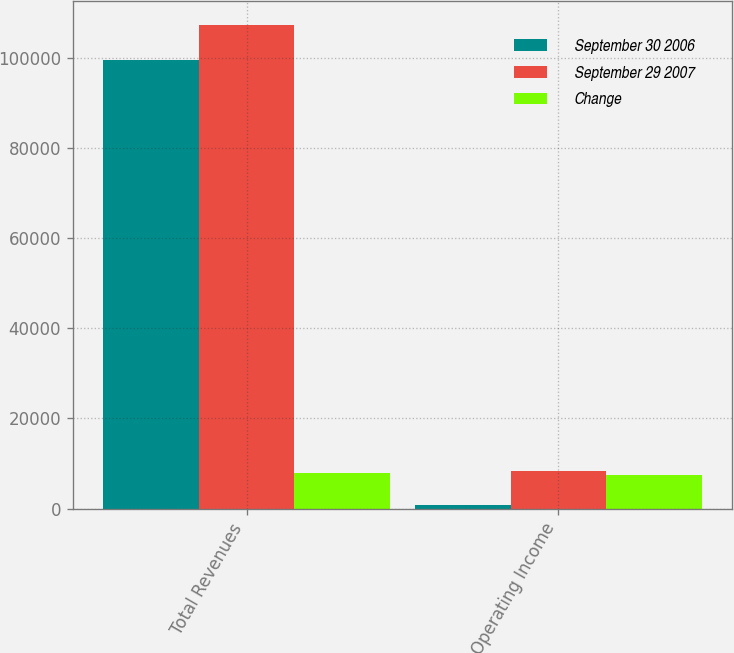Convert chart to OTSL. <chart><loc_0><loc_0><loc_500><loc_500><stacked_bar_chart><ecel><fcel>Total Revenues<fcel>Operating Income<nl><fcel>September 30 2006<fcel>99470<fcel>845<nl><fcel>September 29 2007<fcel>107316<fcel>8312<nl><fcel>Change<fcel>7846<fcel>7467<nl></chart> 